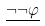Convert formula to latex. <formula><loc_0><loc_0><loc_500><loc_500>\underline { \neg \neg \varphi }</formula> 